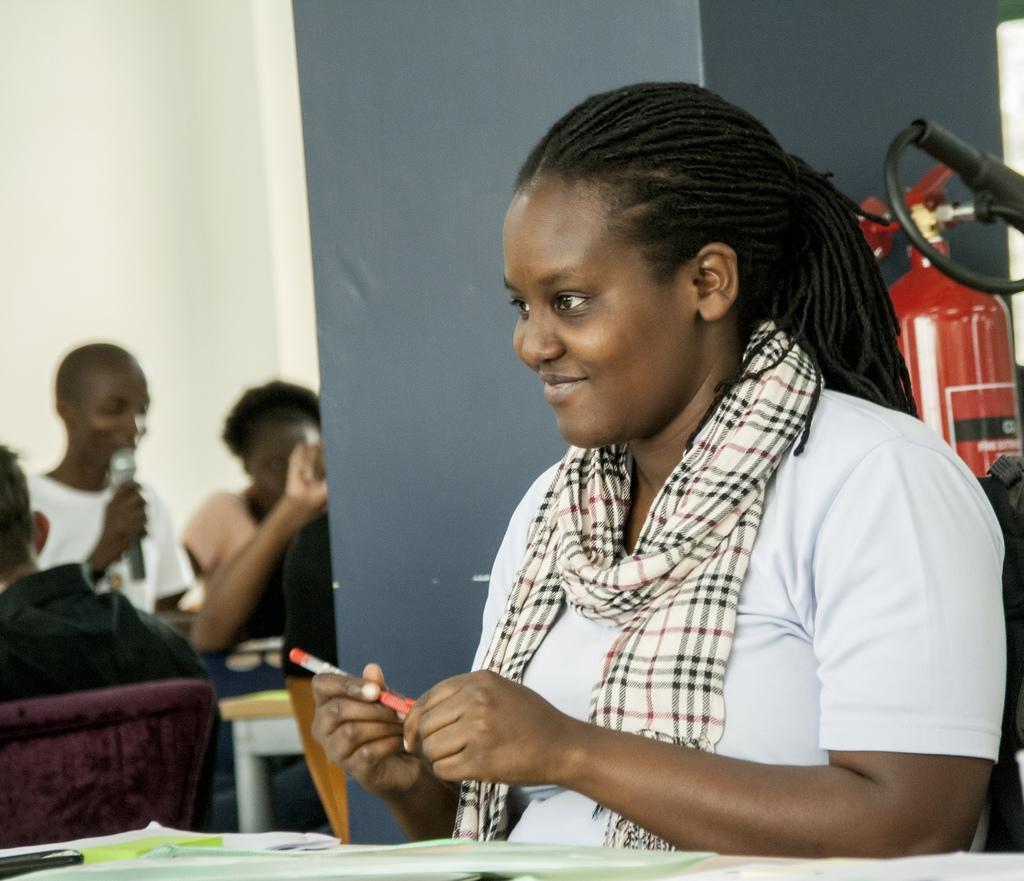Describe this image in one or two sentences. In this image there is a lady wearing t-shirt and scarf she is holding a pen. In the foreground on the table there are papers. In the background there are few other people. This person is holding a mic. The wall is white in color. 